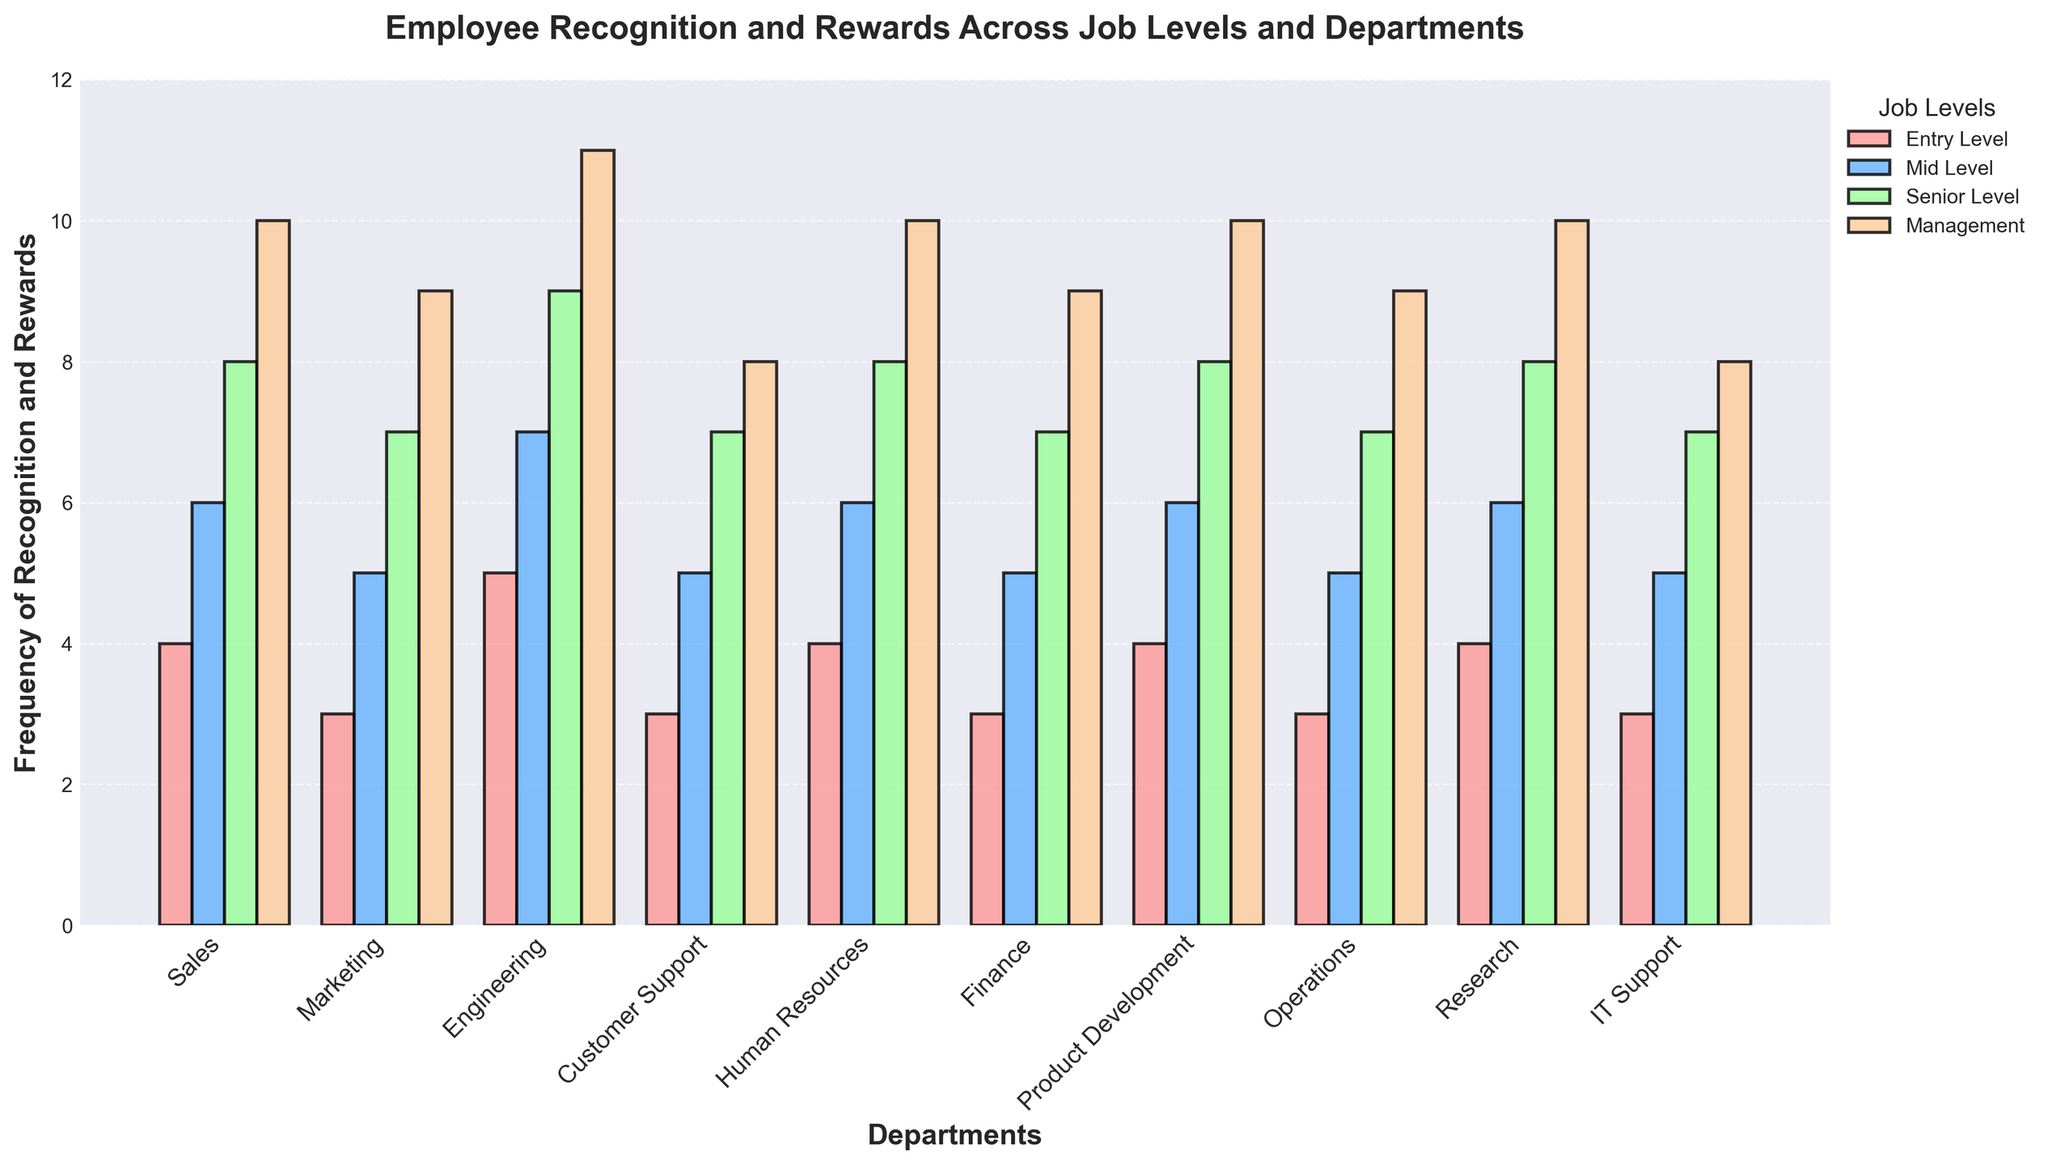What's the average frequency of recognition for Mid-Level employees across all departments? First, sum the frequency values for Mid-Level employees across all departments: 6 + 5 + 7 + 5 + 6 + 5 + 6 + 5 + 6 + 5 = 56. Then, divide this sum by the number of departments (10). Therefore, the average frequency is 56 / 10 = 5.6
Answer: 5.6 Which department has the highest frequency of recognition and rewards for Management level employees? Look at the highest bar corresponding to the Management level employees. By checking the values, Engineering has the highest frequency at 11.
Answer: Engineering Is the frequency of recognition for Entry-Level employees in Sales higher than Entry-Level employees in Finance? Compare the height of the bars for Entry-Level employees in Sales and Finance. Sales has a frequency of 4, while Finance has a frequency of 3. Therefore, Sales is higher.
Answer: Yes What is the difference in the frequency of recognition between Senior-Level employees in Engineering and Customer Support? Find the frequency values for Senior-Level employees in both departments: Engineering has 9 and Customer Support has 7. The difference is 9 - 7 = 2
Answer: 2 Among Mid-Level employees, compare the frequency of recognition between employees in Marketing and Research departments. Which one has a higher frequency, and by how much? Marketing Mid-Level has a frequency of 5, whereas Research Mid-Level has a frequency of 6. The difference is 6 - 5 = 1, with Research being higher.
Answer: Research by 1 Which job level consistently shows the same frequency of recognition across the most departments? Check each job level and count how many times a specific frequency repeats across departments. It appears that 'Entry Level' at 3 and 'Mid Level' at 5 are the most consistent with multiple occurrences.
Answer: Entry Level or Mid Level Considering all job levels within the Human Resources department, what is the total frequency of recognition? Sum the frequencies for each job level within Human Resources: 4 (Entry Level) + 6 (Mid Level) + 8 (Senior Level) + 10 (Management) = 28.
Answer: 28 Which job level in Operations has the lowest frequency of recognition and rewards? Look at the bars for Operations and note the frequencies: Entry Level (3), Mid Level (5), Senior Level (7), and Management (9). Entry Level has the lowest frequency.
Answer: Entry Level What is the median frequency of recognition for all job levels within the IT Support department? For IT Support, the frequencies are: 3 (Entry Level), 5 (Mid Level), 7 (Senior Level), and 8 (Management). Since we have four values, the median will be the average of the second and third values: (5 + 7) / 2 = 6.
Answer: 6 Comparing all departments, in which department is the frequency of recognition for Senior-Level employees equal to 8? Look at the Senior Level frequency across all departments. The departments where the frequency is 8 are Sales, Human Resources, Product Development, and Research.
Answer: Sales, Human Resources, Product Development, Research 